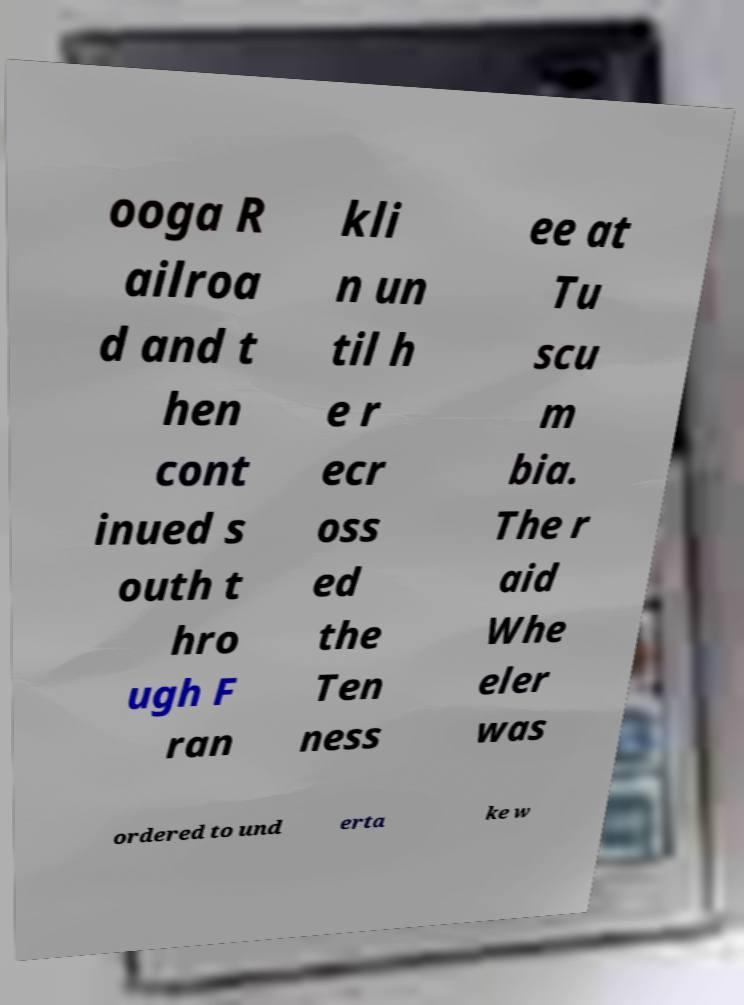Can you read and provide the text displayed in the image?This photo seems to have some interesting text. Can you extract and type it out for me? ooga R ailroa d and t hen cont inued s outh t hro ugh F ran kli n un til h e r ecr oss ed the Ten ness ee at Tu scu m bia. The r aid Whe eler was ordered to und erta ke w 